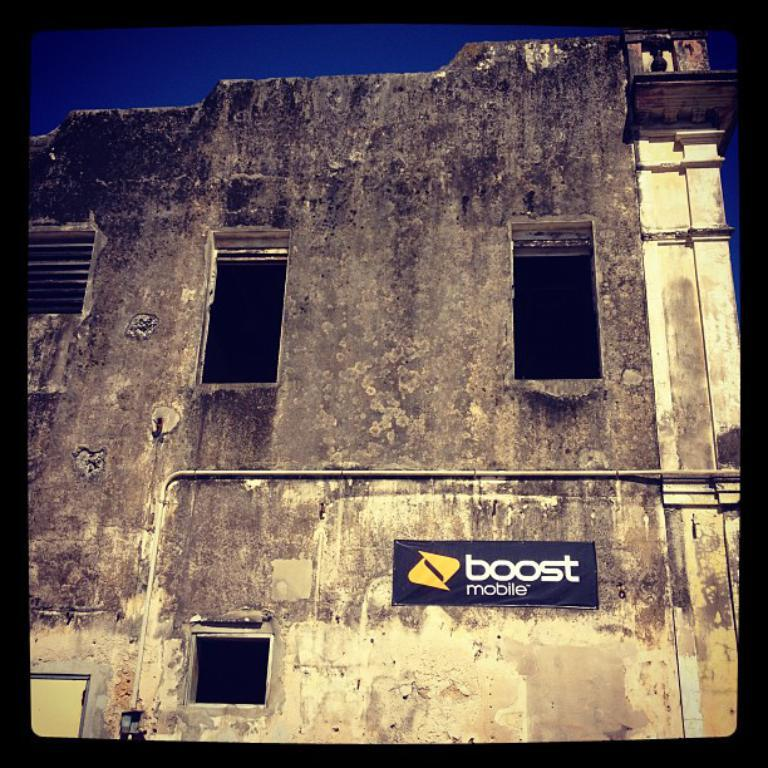What type of structure is present in the image? There is a building in the image. What else can be seen in the image besides the building? There is a board in the image. What part of the natural environment is visible in the image? The sky is visible in the image. What type of action is the crib performing in the image? There is no crib present in the image, so it is not possible to determine any actions performed by a crib. 